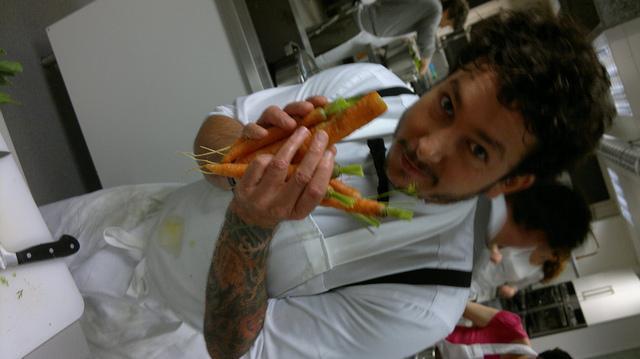How many carrots can be seen?
Give a very brief answer. 1. How many people are there?
Give a very brief answer. 5. 